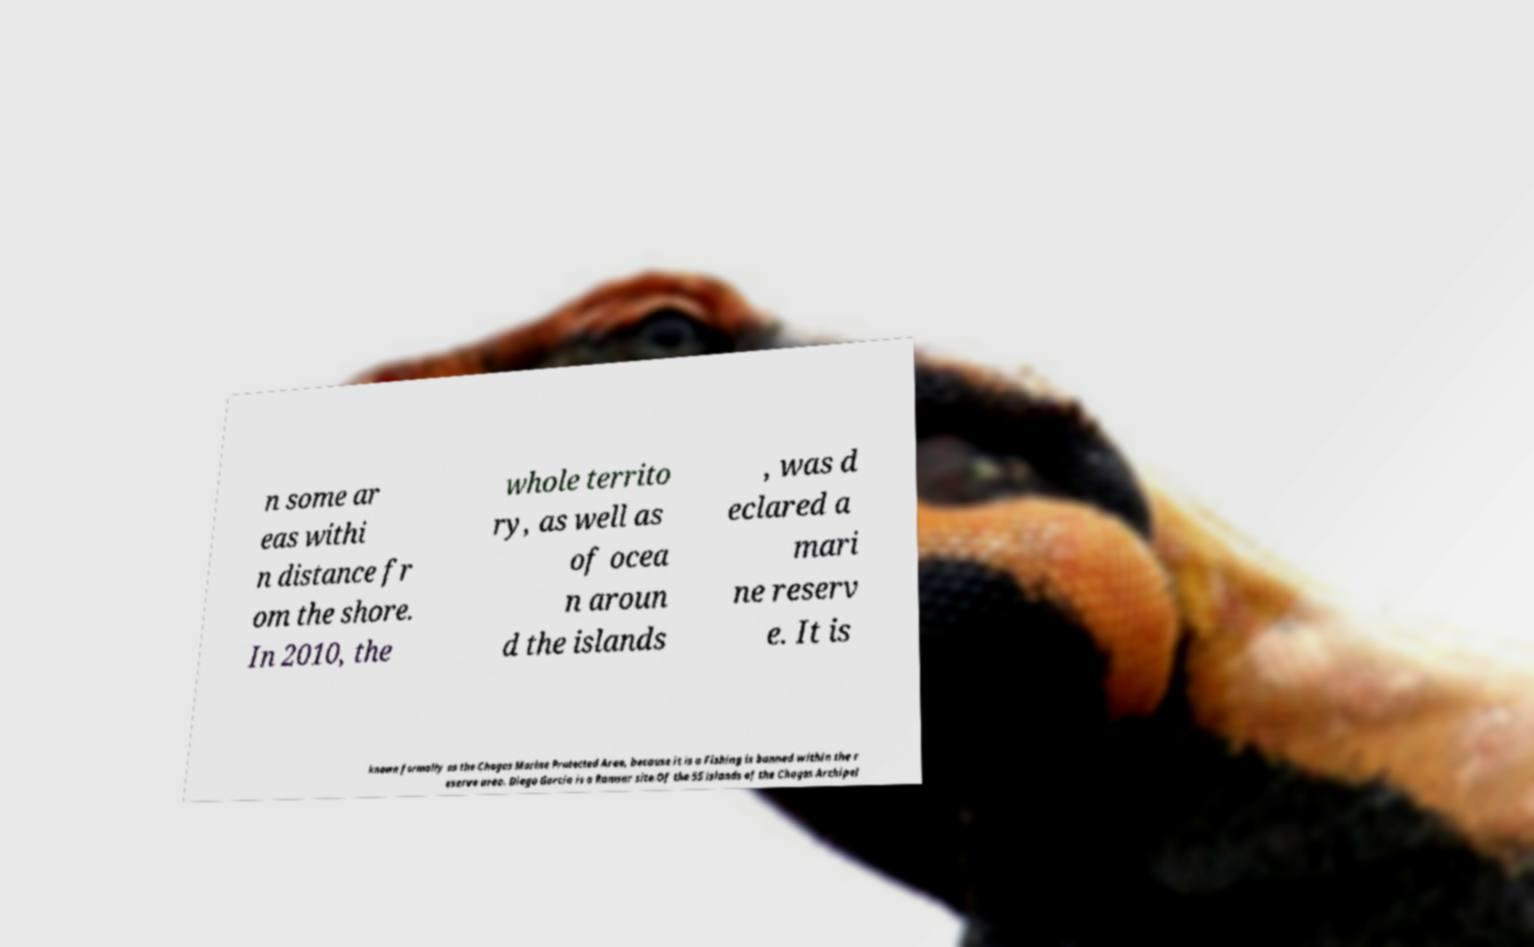I need the written content from this picture converted into text. Can you do that? n some ar eas withi n distance fr om the shore. In 2010, the whole territo ry, as well as of ocea n aroun d the islands , was d eclared a mari ne reserv e. It is known formally as the Chagos Marine Protected Area, because it is a Fishing is banned within the r eserve area. Diego Garcia is a Ramsar site.Of the 55 islands of the Chagos Archipel 